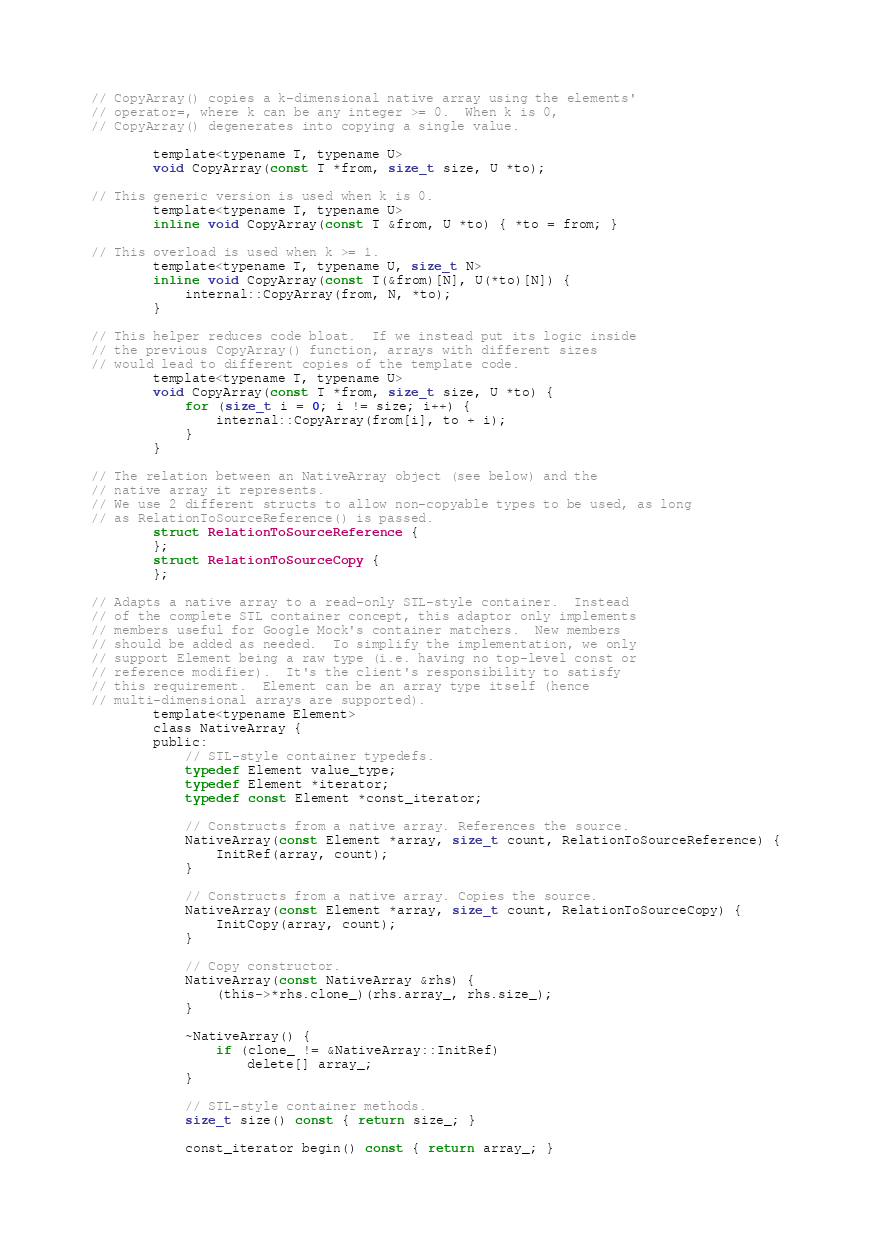Convert code to text. <code><loc_0><loc_0><loc_500><loc_500><_C_>
// CopyArray() copies a k-dimensional native array using the elements'
// operator=, where k can be any integer >= 0.  When k is 0,
// CopyArray() degenerates into copying a single value.

        template<typename T, typename U>
        void CopyArray(const T *from, size_t size, U *to);

// This generic version is used when k is 0.
        template<typename T, typename U>
        inline void CopyArray(const T &from, U *to) { *to = from; }

// This overload is used when k >= 1.
        template<typename T, typename U, size_t N>
        inline void CopyArray(const T(&from)[N], U(*to)[N]) {
            internal::CopyArray(from, N, *to);
        }

// This helper reduces code bloat.  If we instead put its logic inside
// the previous CopyArray() function, arrays with different sizes
// would lead to different copies of the template code.
        template<typename T, typename U>
        void CopyArray(const T *from, size_t size, U *to) {
            for (size_t i = 0; i != size; i++) {
                internal::CopyArray(from[i], to + i);
            }
        }

// The relation between an NativeArray object (see below) and the
// native array it represents.
// We use 2 different structs to allow non-copyable types to be used, as long
// as RelationToSourceReference() is passed.
        struct RelationToSourceReference {
        };
        struct RelationToSourceCopy {
        };

// Adapts a native array to a read-only STL-style container.  Instead
// of the complete STL container concept, this adaptor only implements
// members useful for Google Mock's container matchers.  New members
// should be added as needed.  To simplify the implementation, we only
// support Element being a raw type (i.e. having no top-level const or
// reference modifier).  It's the client's responsibility to satisfy
// this requirement.  Element can be an array type itself (hence
// multi-dimensional arrays are supported).
        template<typename Element>
        class NativeArray {
        public:
            // STL-style container typedefs.
            typedef Element value_type;
            typedef Element *iterator;
            typedef const Element *const_iterator;

            // Constructs from a native array. References the source.
            NativeArray(const Element *array, size_t count, RelationToSourceReference) {
                InitRef(array, count);
            }

            // Constructs from a native array. Copies the source.
            NativeArray(const Element *array, size_t count, RelationToSourceCopy) {
                InitCopy(array, count);
            }

            // Copy constructor.
            NativeArray(const NativeArray &rhs) {
                (this->*rhs.clone_)(rhs.array_, rhs.size_);
            }

            ~NativeArray() {
                if (clone_ != &NativeArray::InitRef)
                    delete[] array_;
            }

            // STL-style container methods.
            size_t size() const { return size_; }

            const_iterator begin() const { return array_; }
</code> 